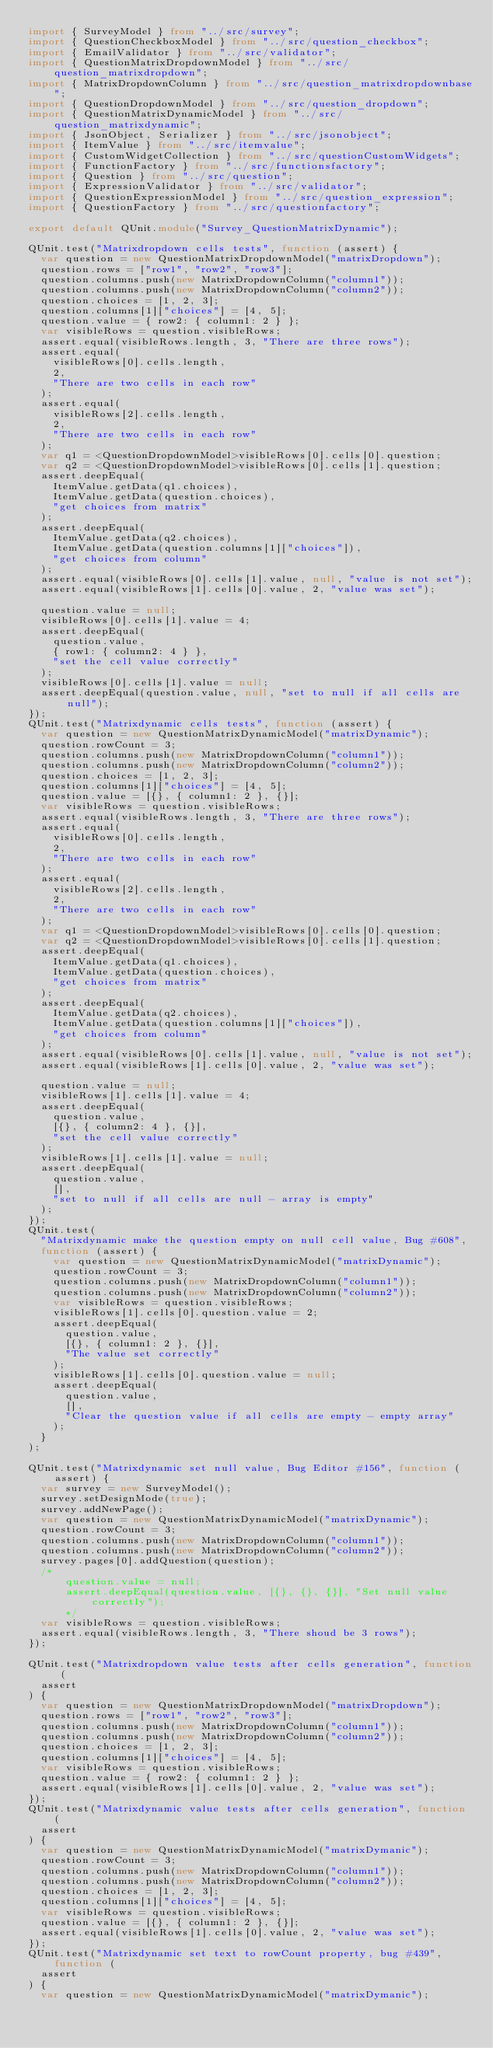<code> <loc_0><loc_0><loc_500><loc_500><_TypeScript_>import { SurveyModel } from "../src/survey";
import { QuestionCheckboxModel } from "../src/question_checkbox";
import { EmailValidator } from "../src/validator";
import { QuestionMatrixDropdownModel } from "../src/question_matrixdropdown";
import { MatrixDropdownColumn } from "../src/question_matrixdropdownbase";
import { QuestionDropdownModel } from "../src/question_dropdown";
import { QuestionMatrixDynamicModel } from "../src/question_matrixdynamic";
import { JsonObject, Serializer } from "../src/jsonobject";
import { ItemValue } from "../src/itemvalue";
import { CustomWidgetCollection } from "../src/questionCustomWidgets";
import { FunctionFactory } from "../src/functionsfactory";
import { Question } from "../src/question";
import { ExpressionValidator } from "../src/validator";
import { QuestionExpressionModel } from "../src/question_expression";
import { QuestionFactory } from "../src/questionfactory";

export default QUnit.module("Survey_QuestionMatrixDynamic");

QUnit.test("Matrixdropdown cells tests", function (assert) {
  var question = new QuestionMatrixDropdownModel("matrixDropdown");
  question.rows = ["row1", "row2", "row3"];
  question.columns.push(new MatrixDropdownColumn("column1"));
  question.columns.push(new MatrixDropdownColumn("column2"));
  question.choices = [1, 2, 3];
  question.columns[1]["choices"] = [4, 5];
  question.value = { row2: { column1: 2 } };
  var visibleRows = question.visibleRows;
  assert.equal(visibleRows.length, 3, "There are three rows");
  assert.equal(
    visibleRows[0].cells.length,
    2,
    "There are two cells in each row"
  );
  assert.equal(
    visibleRows[2].cells.length,
    2,
    "There are two cells in each row"
  );
  var q1 = <QuestionDropdownModel>visibleRows[0].cells[0].question;
  var q2 = <QuestionDropdownModel>visibleRows[0].cells[1].question;
  assert.deepEqual(
    ItemValue.getData(q1.choices),
    ItemValue.getData(question.choices),
    "get choices from matrix"
  );
  assert.deepEqual(
    ItemValue.getData(q2.choices),
    ItemValue.getData(question.columns[1]["choices"]),
    "get choices from column"
  );
  assert.equal(visibleRows[0].cells[1].value, null, "value is not set");
  assert.equal(visibleRows[1].cells[0].value, 2, "value was set");

  question.value = null;
  visibleRows[0].cells[1].value = 4;
  assert.deepEqual(
    question.value,
    { row1: { column2: 4 } },
    "set the cell value correctly"
  );
  visibleRows[0].cells[1].value = null;
  assert.deepEqual(question.value, null, "set to null if all cells are null");
});
QUnit.test("Matrixdynamic cells tests", function (assert) {
  var question = new QuestionMatrixDynamicModel("matrixDynamic");
  question.rowCount = 3;
  question.columns.push(new MatrixDropdownColumn("column1"));
  question.columns.push(new MatrixDropdownColumn("column2"));
  question.choices = [1, 2, 3];
  question.columns[1]["choices"] = [4, 5];
  question.value = [{}, { column1: 2 }, {}];
  var visibleRows = question.visibleRows;
  assert.equal(visibleRows.length, 3, "There are three rows");
  assert.equal(
    visibleRows[0].cells.length,
    2,
    "There are two cells in each row"
  );
  assert.equal(
    visibleRows[2].cells.length,
    2,
    "There are two cells in each row"
  );
  var q1 = <QuestionDropdownModel>visibleRows[0].cells[0].question;
  var q2 = <QuestionDropdownModel>visibleRows[0].cells[1].question;
  assert.deepEqual(
    ItemValue.getData(q1.choices),
    ItemValue.getData(question.choices),
    "get choices from matrix"
  );
  assert.deepEqual(
    ItemValue.getData(q2.choices),
    ItemValue.getData(question.columns[1]["choices"]),
    "get choices from column"
  );
  assert.equal(visibleRows[0].cells[1].value, null, "value is not set");
  assert.equal(visibleRows[1].cells[0].value, 2, "value was set");

  question.value = null;
  visibleRows[1].cells[1].value = 4;
  assert.deepEqual(
    question.value,
    [{}, { column2: 4 }, {}],
    "set the cell value correctly"
  );
  visibleRows[1].cells[1].value = null;
  assert.deepEqual(
    question.value,
    [],
    "set to null if all cells are null - array is empty"
  );
});
QUnit.test(
  "Matrixdynamic make the question empty on null cell value, Bug #608",
  function (assert) {
    var question = new QuestionMatrixDynamicModel("matrixDynamic");
    question.rowCount = 3;
    question.columns.push(new MatrixDropdownColumn("column1"));
    question.columns.push(new MatrixDropdownColumn("column2"));
    var visibleRows = question.visibleRows;
    visibleRows[1].cells[0].question.value = 2;
    assert.deepEqual(
      question.value,
      [{}, { column1: 2 }, {}],
      "The value set correctly"
    );
    visibleRows[1].cells[0].question.value = null;
    assert.deepEqual(
      question.value,
      [],
      "Clear the question value if all cells are empty - empty array"
    );
  }
);

QUnit.test("Matrixdynamic set null value, Bug Editor #156", function (assert) {
  var survey = new SurveyModel();
  survey.setDesignMode(true);
  survey.addNewPage();
  var question = new QuestionMatrixDynamicModel("matrixDynamic");
  question.rowCount = 3;
  question.columns.push(new MatrixDropdownColumn("column1"));
  question.columns.push(new MatrixDropdownColumn("column2"));
  survey.pages[0].addQuestion(question);
  /*
      question.value = null;
      assert.deepEqual(question.value, [{}, {}, {}], "Set null value correctly");
      */
  var visibleRows = question.visibleRows;
  assert.equal(visibleRows.length, 3, "There shoud be 3 rows");
});

QUnit.test("Matrixdropdown value tests after cells generation", function (
  assert
) {
  var question = new QuestionMatrixDropdownModel("matrixDropdown");
  question.rows = ["row1", "row2", "row3"];
  question.columns.push(new MatrixDropdownColumn("column1"));
  question.columns.push(new MatrixDropdownColumn("column2"));
  question.choices = [1, 2, 3];
  question.columns[1]["choices"] = [4, 5];
  var visibleRows = question.visibleRows;
  question.value = { row2: { column1: 2 } };
  assert.equal(visibleRows[1].cells[0].value, 2, "value was set");
});
QUnit.test("Matrixdynamic value tests after cells generation", function (
  assert
) {
  var question = new QuestionMatrixDynamicModel("matrixDymanic");
  question.rowCount = 3;
  question.columns.push(new MatrixDropdownColumn("column1"));
  question.columns.push(new MatrixDropdownColumn("column2"));
  question.choices = [1, 2, 3];
  question.columns[1]["choices"] = [4, 5];
  var visibleRows = question.visibleRows;
  question.value = [{}, { column1: 2 }, {}];
  assert.equal(visibleRows[1].cells[0].value, 2, "value was set");
});
QUnit.test("Matrixdynamic set text to rowCount property, bug #439", function (
  assert
) {
  var question = new QuestionMatrixDynamicModel("matrixDymanic");</code> 